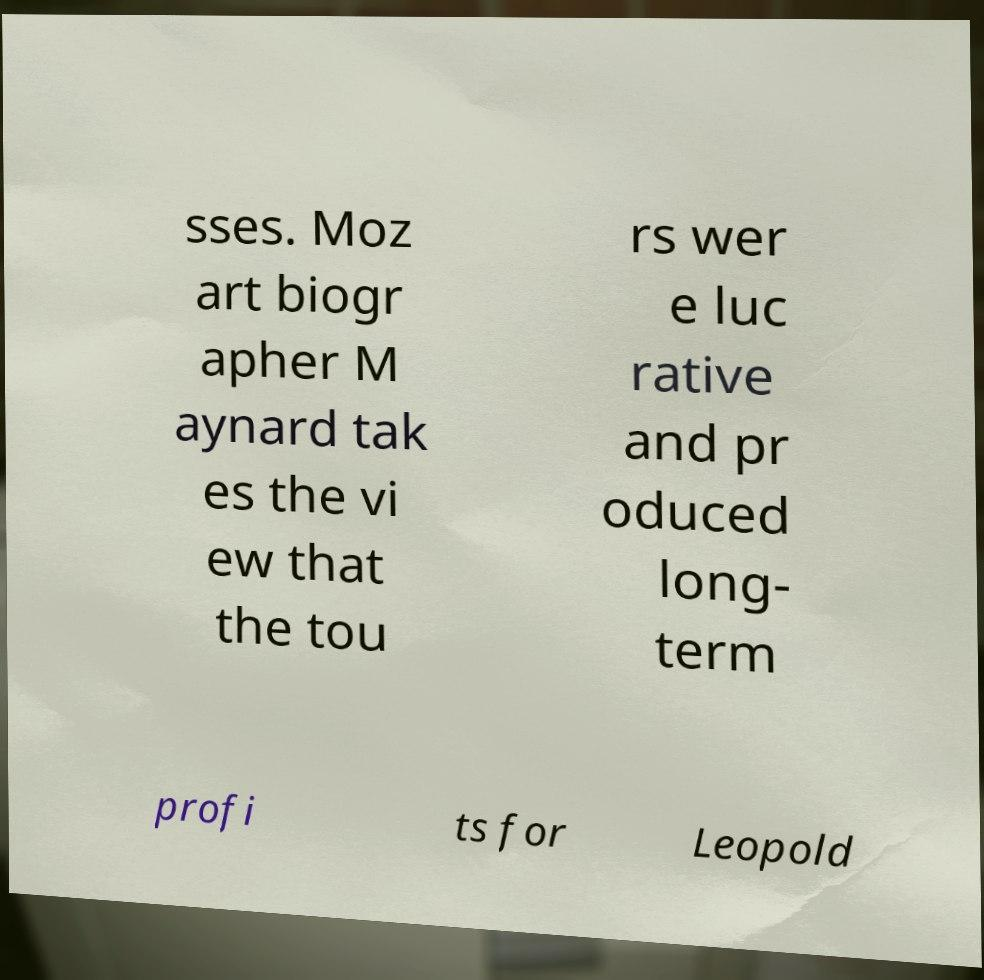For documentation purposes, I need the text within this image transcribed. Could you provide that? sses. Moz art biogr apher M aynard tak es the vi ew that the tou rs wer e luc rative and pr oduced long- term profi ts for Leopold 